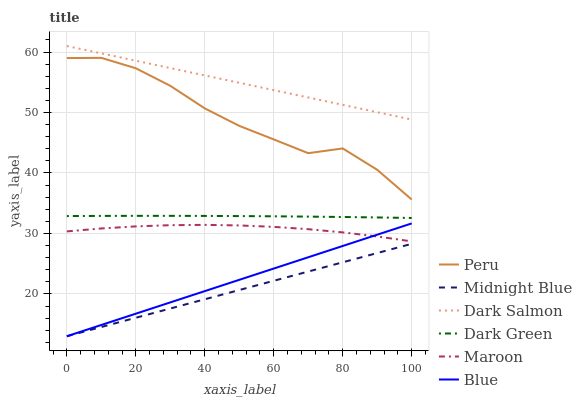Does Midnight Blue have the minimum area under the curve?
Answer yes or no. Yes. Does Dark Salmon have the maximum area under the curve?
Answer yes or no. Yes. Does Dark Salmon have the minimum area under the curve?
Answer yes or no. No. Does Midnight Blue have the maximum area under the curve?
Answer yes or no. No. Is Blue the smoothest?
Answer yes or no. Yes. Is Peru the roughest?
Answer yes or no. Yes. Is Midnight Blue the smoothest?
Answer yes or no. No. Is Midnight Blue the roughest?
Answer yes or no. No. Does Blue have the lowest value?
Answer yes or no. Yes. Does Dark Salmon have the lowest value?
Answer yes or no. No. Does Dark Salmon have the highest value?
Answer yes or no. Yes. Does Midnight Blue have the highest value?
Answer yes or no. No. Is Maroon less than Dark Salmon?
Answer yes or no. Yes. Is Dark Salmon greater than Blue?
Answer yes or no. Yes. Does Midnight Blue intersect Blue?
Answer yes or no. Yes. Is Midnight Blue less than Blue?
Answer yes or no. No. Is Midnight Blue greater than Blue?
Answer yes or no. No. Does Maroon intersect Dark Salmon?
Answer yes or no. No. 